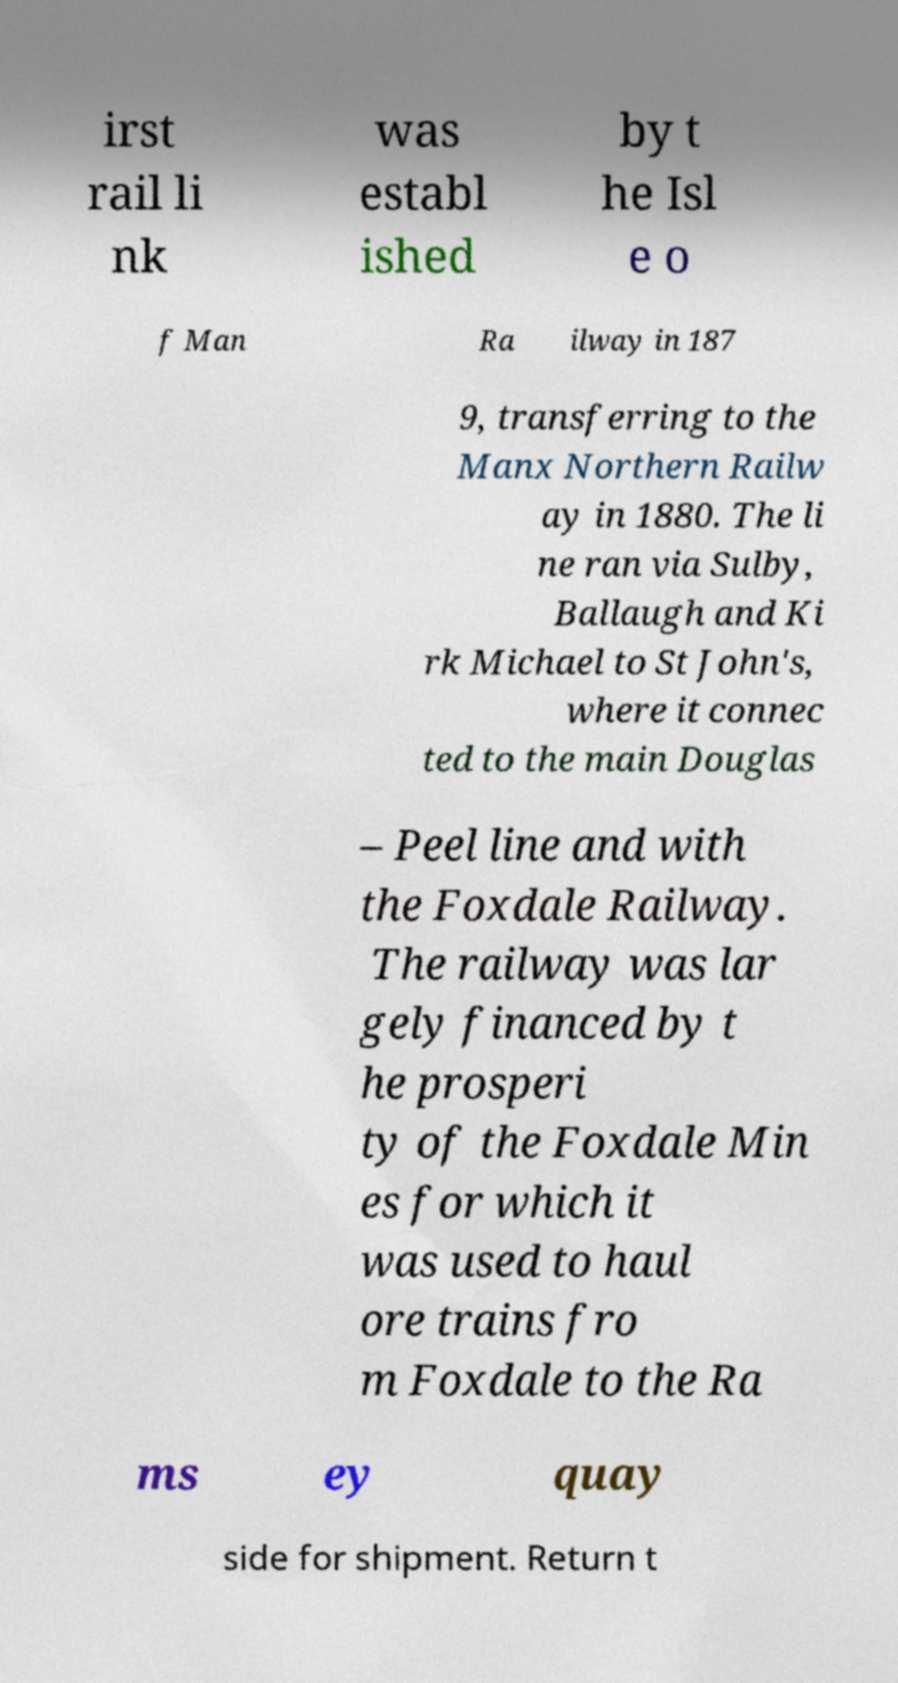Could you extract and type out the text from this image? irst rail li nk was establ ished by t he Isl e o f Man Ra ilway in 187 9, transferring to the Manx Northern Railw ay in 1880. The li ne ran via Sulby, Ballaugh and Ki rk Michael to St John's, where it connec ted to the main Douglas – Peel line and with the Foxdale Railway. The railway was lar gely financed by t he prosperi ty of the Foxdale Min es for which it was used to haul ore trains fro m Foxdale to the Ra ms ey quay side for shipment. Return t 